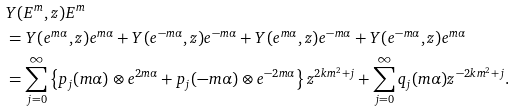Convert formula to latex. <formula><loc_0><loc_0><loc_500><loc_500>& Y ( E ^ { m } , z ) E ^ { m } \\ & = Y ( e ^ { m \alpha } , z ) e ^ { m \alpha } + Y ( e ^ { - m \alpha } , z ) e ^ { - m \alpha } + Y ( e ^ { m \alpha } , z ) e ^ { - m \alpha } + Y ( e ^ { - m \alpha } , z ) e ^ { m \alpha } \\ & = \sum _ { j = 0 } ^ { \infty } \left \{ p _ { j } ( m \alpha ) \otimes e ^ { 2 m \alpha } + p _ { j } ( - m \alpha ) \otimes e ^ { - 2 m \alpha } \right \} z ^ { 2 k m ^ { 2 } + j } + \sum _ { j = 0 } ^ { \infty } q _ { j } ( m \alpha ) z ^ { - 2 k m ^ { 2 } + j } .</formula> 